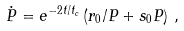Convert formula to latex. <formula><loc_0><loc_0><loc_500><loc_500>\dot { P } = e ^ { - 2 t / t _ { c } } \left ( { r _ { 0 } } / { P } + s _ { 0 } P \right ) \, ,</formula> 